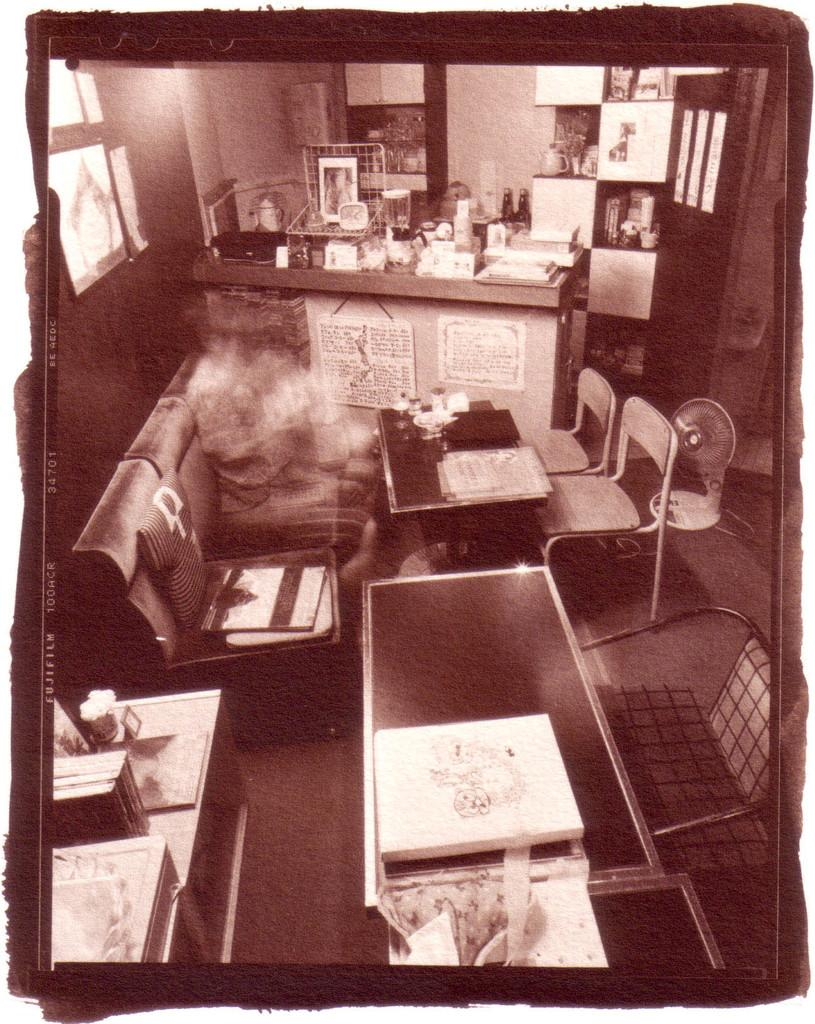What type of furniture is present in the image? There are tables and chairs in the image. What medical device can be seen in the image? There is a respirator in the image. What is placed on the respirator? Objects are placed on the respirator. How many sails can be seen on the swing in the image? There is no swing or sail present in the image. What type of number is written on the respirator in the image? There is no number visible on the respirator in the image. 